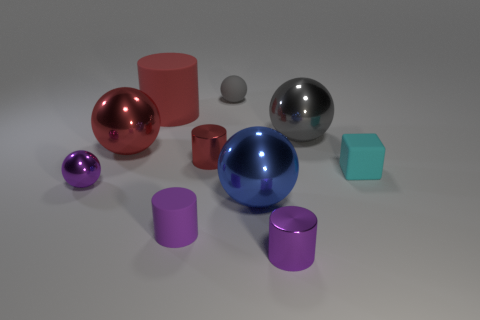There is a large shiny object that is the same color as the large cylinder; what shape is it?
Give a very brief answer. Sphere. Are there fewer red metallic cylinders that are to the right of the blue thing than small green matte cubes?
Offer a very short reply. No. How many other things are the same size as the purple ball?
Provide a short and direct response. 5. There is a purple shiny object left of the tiny purple matte cylinder; does it have the same shape as the gray shiny thing?
Provide a short and direct response. Yes. Is the number of big red metallic things that are in front of the tiny matte cylinder greater than the number of large gray metallic balls?
Provide a succinct answer. No. There is a small purple thing that is to the right of the tiny purple sphere and on the left side of the small purple metal cylinder; what is it made of?
Your response must be concise. Rubber. Are there any other things that are the same shape as the large blue thing?
Your response must be concise. Yes. What number of tiny things are on the left side of the tiny gray sphere and to the right of the gray metallic object?
Provide a short and direct response. 0. What material is the tiny cube?
Provide a short and direct response. Rubber. Are there the same number of cylinders that are right of the tiny cyan rubber block and gray metallic balls?
Make the answer very short. No. 